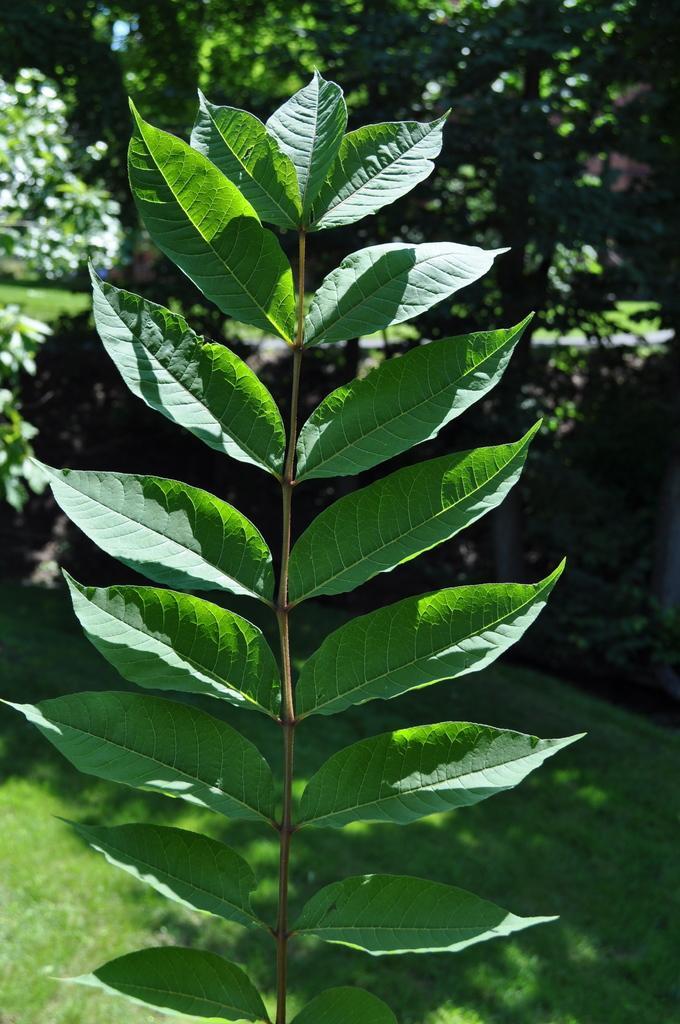How would you summarize this image in a sentence or two? Here we can see a stem with leaves. This is grass. In the background there are trees. 